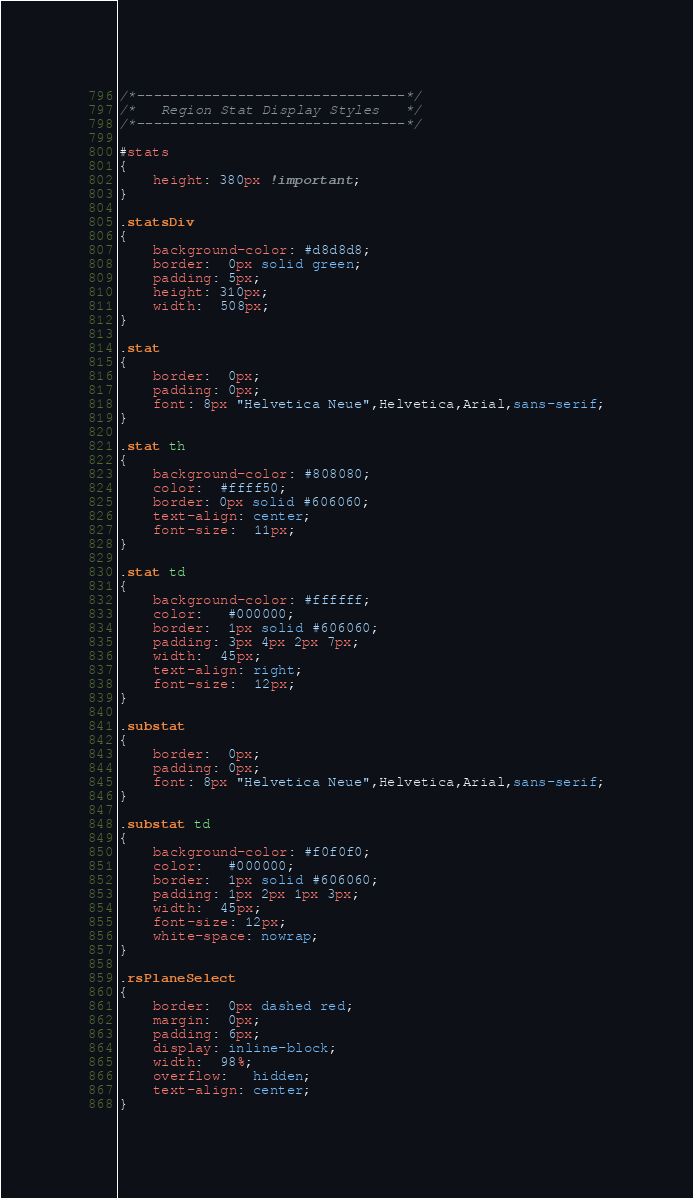Convert code to text. <code><loc_0><loc_0><loc_500><loc_500><_CSS_>/*--------------------------------*/
/*   Region Stat Display Styles   */
/*--------------------------------*/

#stats
{
	height: 380px !important;
}

.statsDiv 
{
	background-color: #d8d8d8; 
	border:  0px solid green; 
	padding: 5px;
	height: 310px;
	width:  508px;
}

.stat    
{
	border:  0px; 
	padding: 0px; 
	font: 8px "Helvetica Neue",Helvetica,Arial,sans-serif;
}

.stat th 
{
	background-color: #808080;
	color:  #ffff50; 
	border: 0px solid #606060;  	
	text-align: center;
	font-size:  11px; 
}

.stat td 
{
	background-color: #ffffff; 
	color:   #000000; 
	border:  1px solid #606060;
	padding: 3px 4px 2px 7px; 
	width:  45px; 
	text-align: right;
	font-size:  12px; 
}

.substat    
{
	border:  0px; 
	padding: 0px; 
	font: 8px "Helvetica Neue",Helvetica,Arial,sans-serif;
}

.substat td 
{
	background-color: #f0f0f0; 
	color:   #000000; 
	border:  1px solid #606060;
	padding: 1px 2px 1px 3px;
	width:  45px; 
	font-size: 12px; 
	white-space: nowrap; 
}

.rsPlaneSelect 
{
	border:  0px dashed red;
	margin:  0px;
	padding: 6px;
	display: inline-block;
	width:  98%;
	overflow:   hidden;
	text-align: center; 
}

</code> 